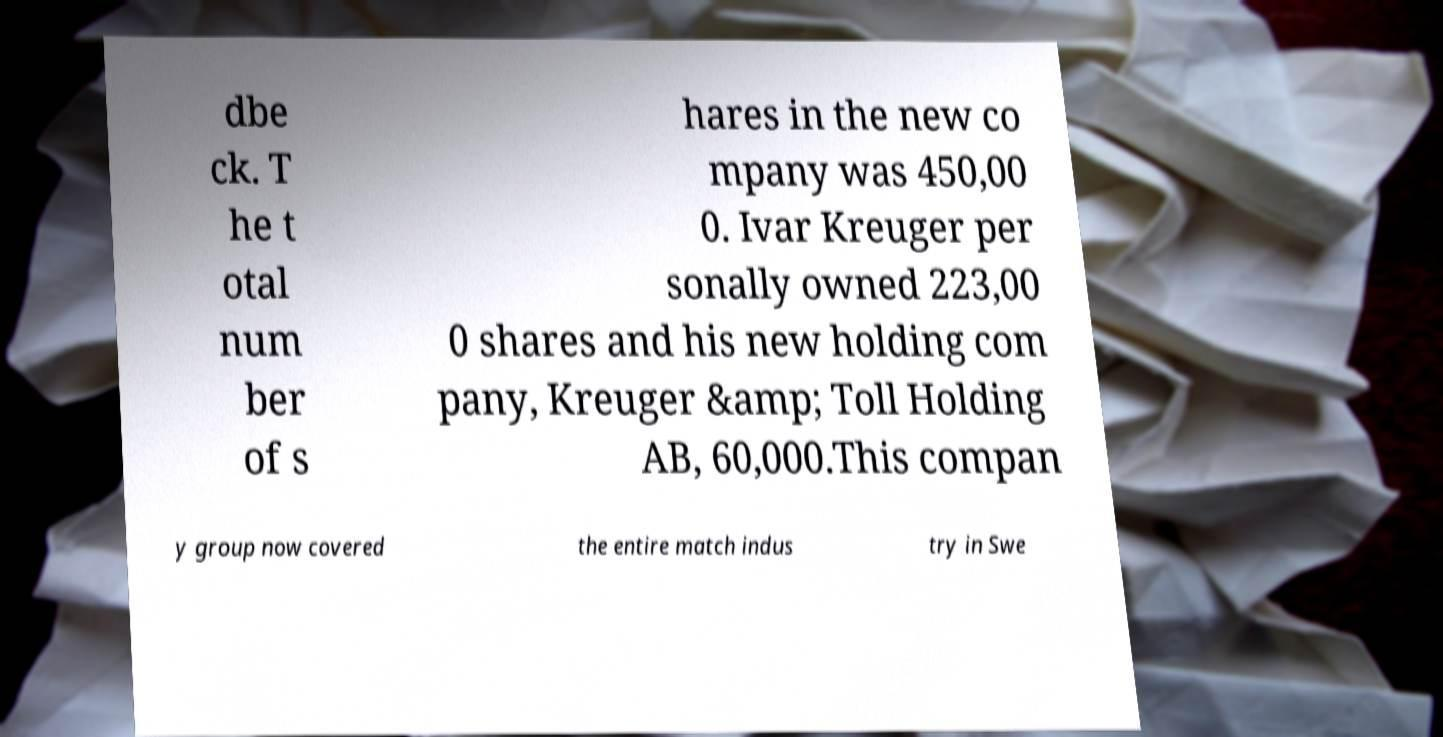What messages or text are displayed in this image? I need them in a readable, typed format. dbe ck. T he t otal num ber of s hares in the new co mpany was 450,00 0. Ivar Kreuger per sonally owned 223,00 0 shares and his new holding com pany, Kreuger &amp; Toll Holding AB, 60,000.This compan y group now covered the entire match indus try in Swe 